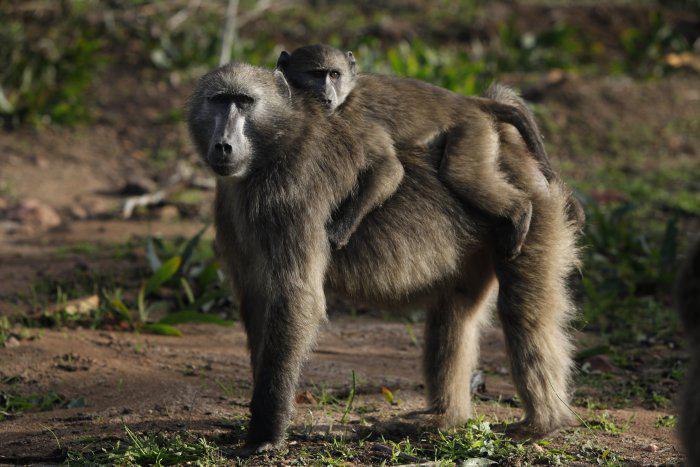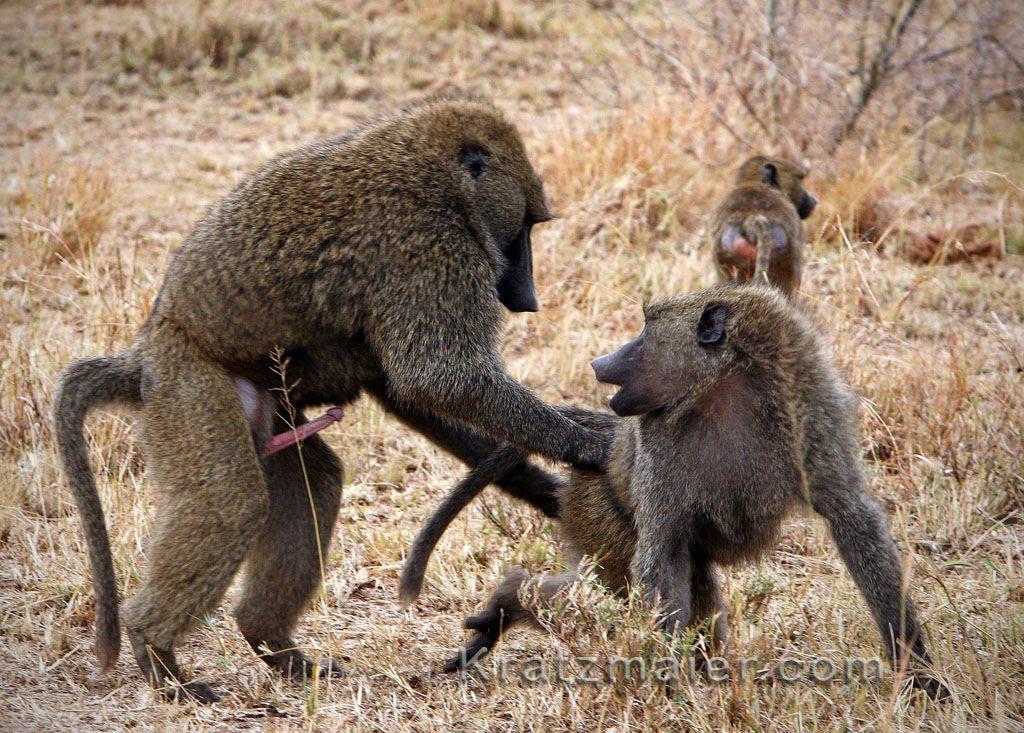The first image is the image on the left, the second image is the image on the right. Assess this claim about the two images: "One monkey is holding onto another monkey from it's back in one of the images.". Correct or not? Answer yes or no. Yes. 